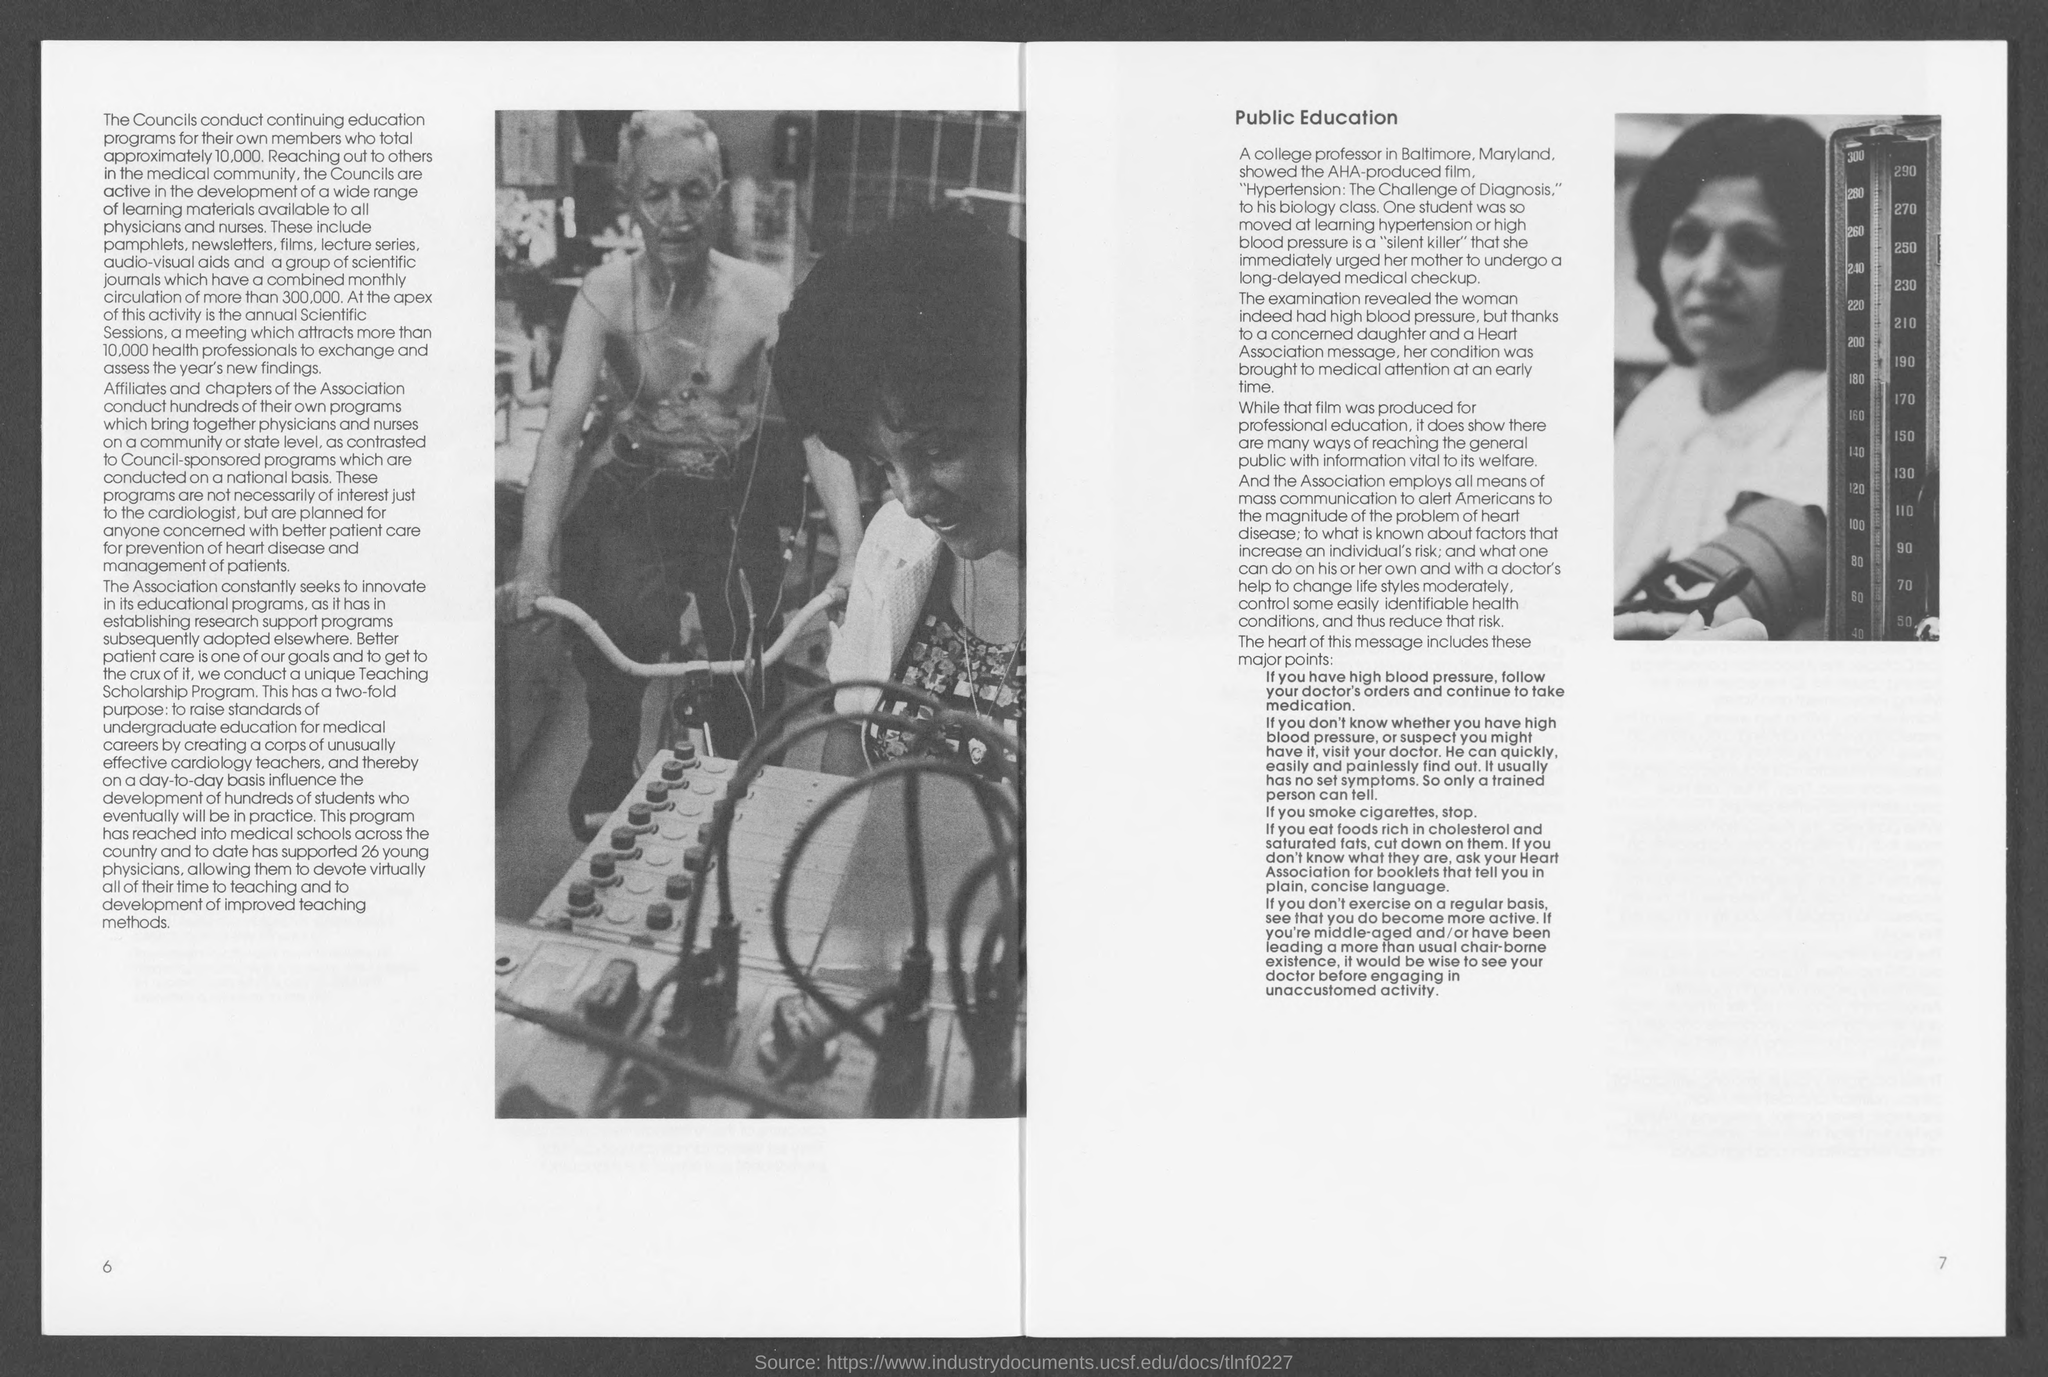What is the number at bottom-left corner of the page ?
Provide a succinct answer. 6. What is the number at bottom- right corner of the page ?
Your response must be concise. 7. 